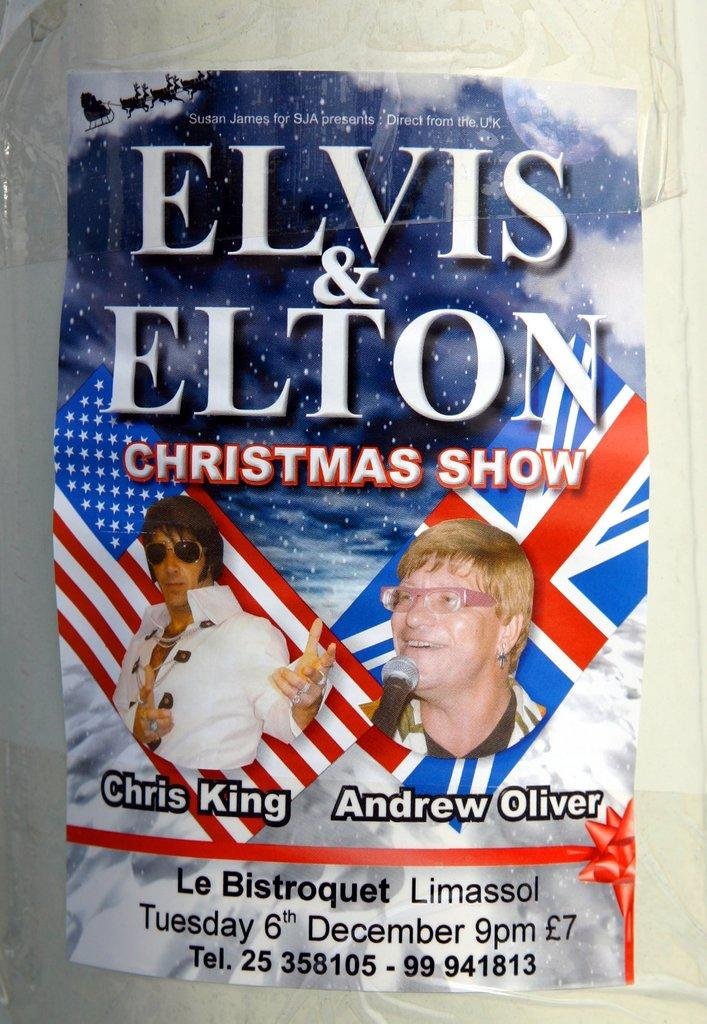What is present in the image that features visual content? There is a poster in the image. What can be seen on the poster? The poster has images of two people. Is there any text on the poster? Yes, there is written matter on the poster. What type of shoe is being advertised on the poster? There is no shoe being advertised on the poster; it features images of two people and written matter. --- Facts: 1. There is a person sitting on a chair in the image. 2. The person is holding a book. 3. The book has a red cover. 4. There is a table next to the chair. 5. The table has a lamp on it. Absurd Topics: dance, ocean, birdhouse Conversation: What is the person in the image doing? The person is sitting on a chair in the image. What is the person holding while sitting on the chair? The person is holding a book. Can you describe the book? The book has a red cover. What is located next to the chair? There is a table next to the chair. What object can be seen on the table? The table has a lamp on it. Reasoning: Let's think step by step in order to produce the conversation. We start by identifying the main subject in the image, which is the person sitting on a chair. Then, we expand the conversation to include the specific details about the person's actions and the objects around them, such as the book, the table, and the lamp. Each question is designed to elicit a specific detail about the image that is known from the provided facts. Absurd Question/Answer: Can you see any ocean waves in the background of the image? There is no ocean or waves visible in the image; it features a person sitting on a chair, holding a book, and a table with a lamp. 